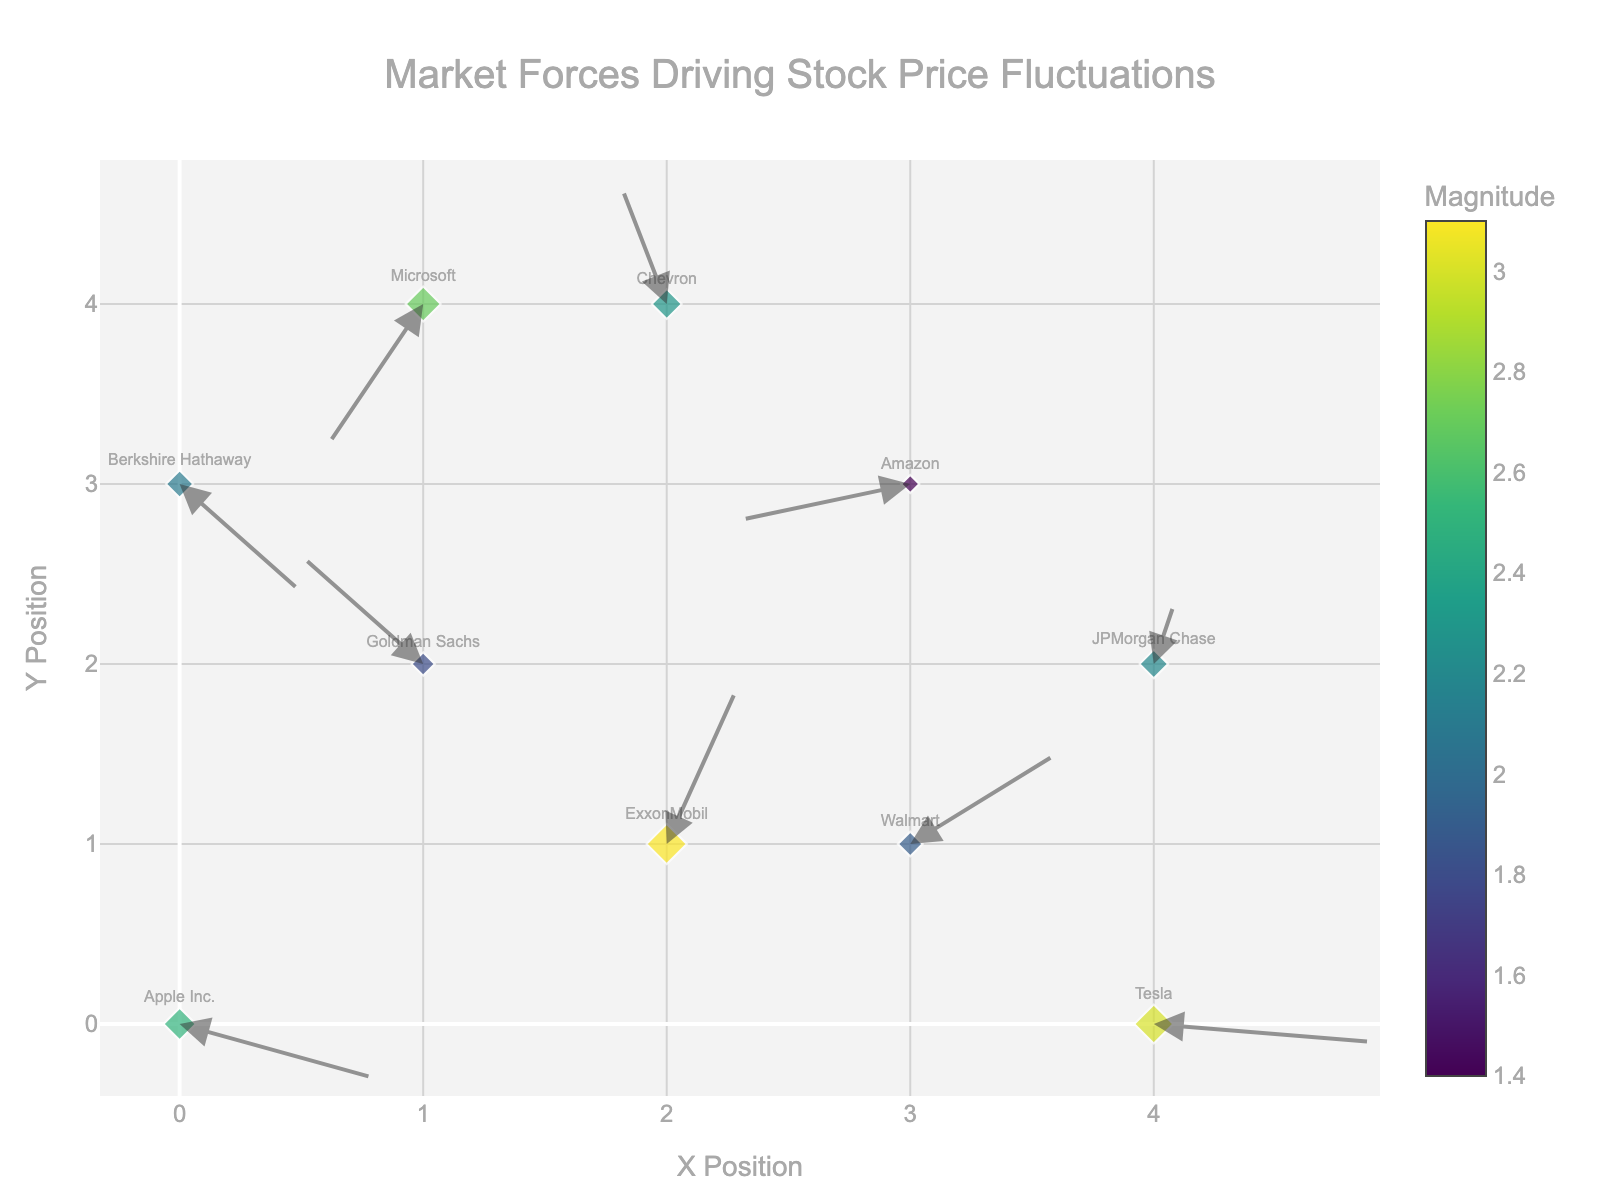What is the title of the quiver plot? The title is displayed prominently at the top of the plot. It helps viewers quickly understand what the figure represents.
Answer: "Market Forces Driving Stock Price Fluctuations" How many companies are represented in this quiver plot? Each company is depicted by a marker on the plot. Count the total number of markers with company names.
Answer: 10 Which company has the highest magnitude? By examining the color scale and the size of the markers, find the company with the largest magnitude.
Answer: "ExxonMobil" Which company has its price direction changing the least negatively on the x-axis? Check the arrows pointing to the right (positive x-component) and identify the company with the smallest positive x-component.
Answer: "JPMorgan Chase" What's the average magnitude of all companies? Add up all the magnitude values and divide by the number of companies. Magnitude values are: 2.5, 1.8, 3.1, 1.4, 2.2, 2.7, 1.9, 2.3, 3.0, 2.1. So, the average is (2.5 + 1.8 + 3.1 + 1.4 + 2.2 + 2.7 + 1.9 + 2.3 + 3.0 + 2.1) / 10 = 22 / 10 = 2.2
Answer: 2.2 Compare Tesla and Amazon: Which company has a more significant decline in stock price on the x-axis? Look at the x-component of the directional arrows for both companies. Tesla has a decline indicated by a minimal negative x-component, while Amazon has a larger negative x-component.
Answer: "Amazon" What is the color range representing the magnitude values in the plot? Check the color bar on the plot which maps magnitude values to colors.
Answer: From blue to yellow Which company has its stock price influenced most positively on the y-axis? Find the company with the highest positive y-component of the directional arrow, indicating an upward movement in stock price.
Answer: "ExxonMobil" What is the x and y position of Apple Inc.? Locate Apple Inc. marker on the plot and note its coordinates on the x and y axes.
Answer: (0, 0) Which companies have a negative y-component in their stock price movement? Identify arrows pointing downward, indicating a negative y-component, and list the respective companies.
Answer: "Apple Inc.", "Microsoft", "Berkshire Hathaway", "Amazon", "Tesla" 